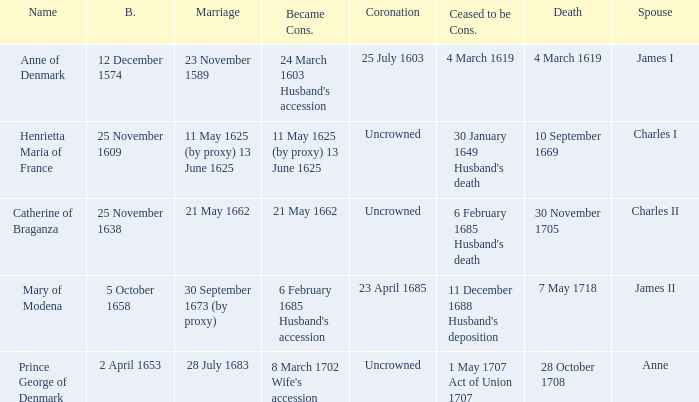When was the date of death for the person married to Charles II? 30 November 1705. 